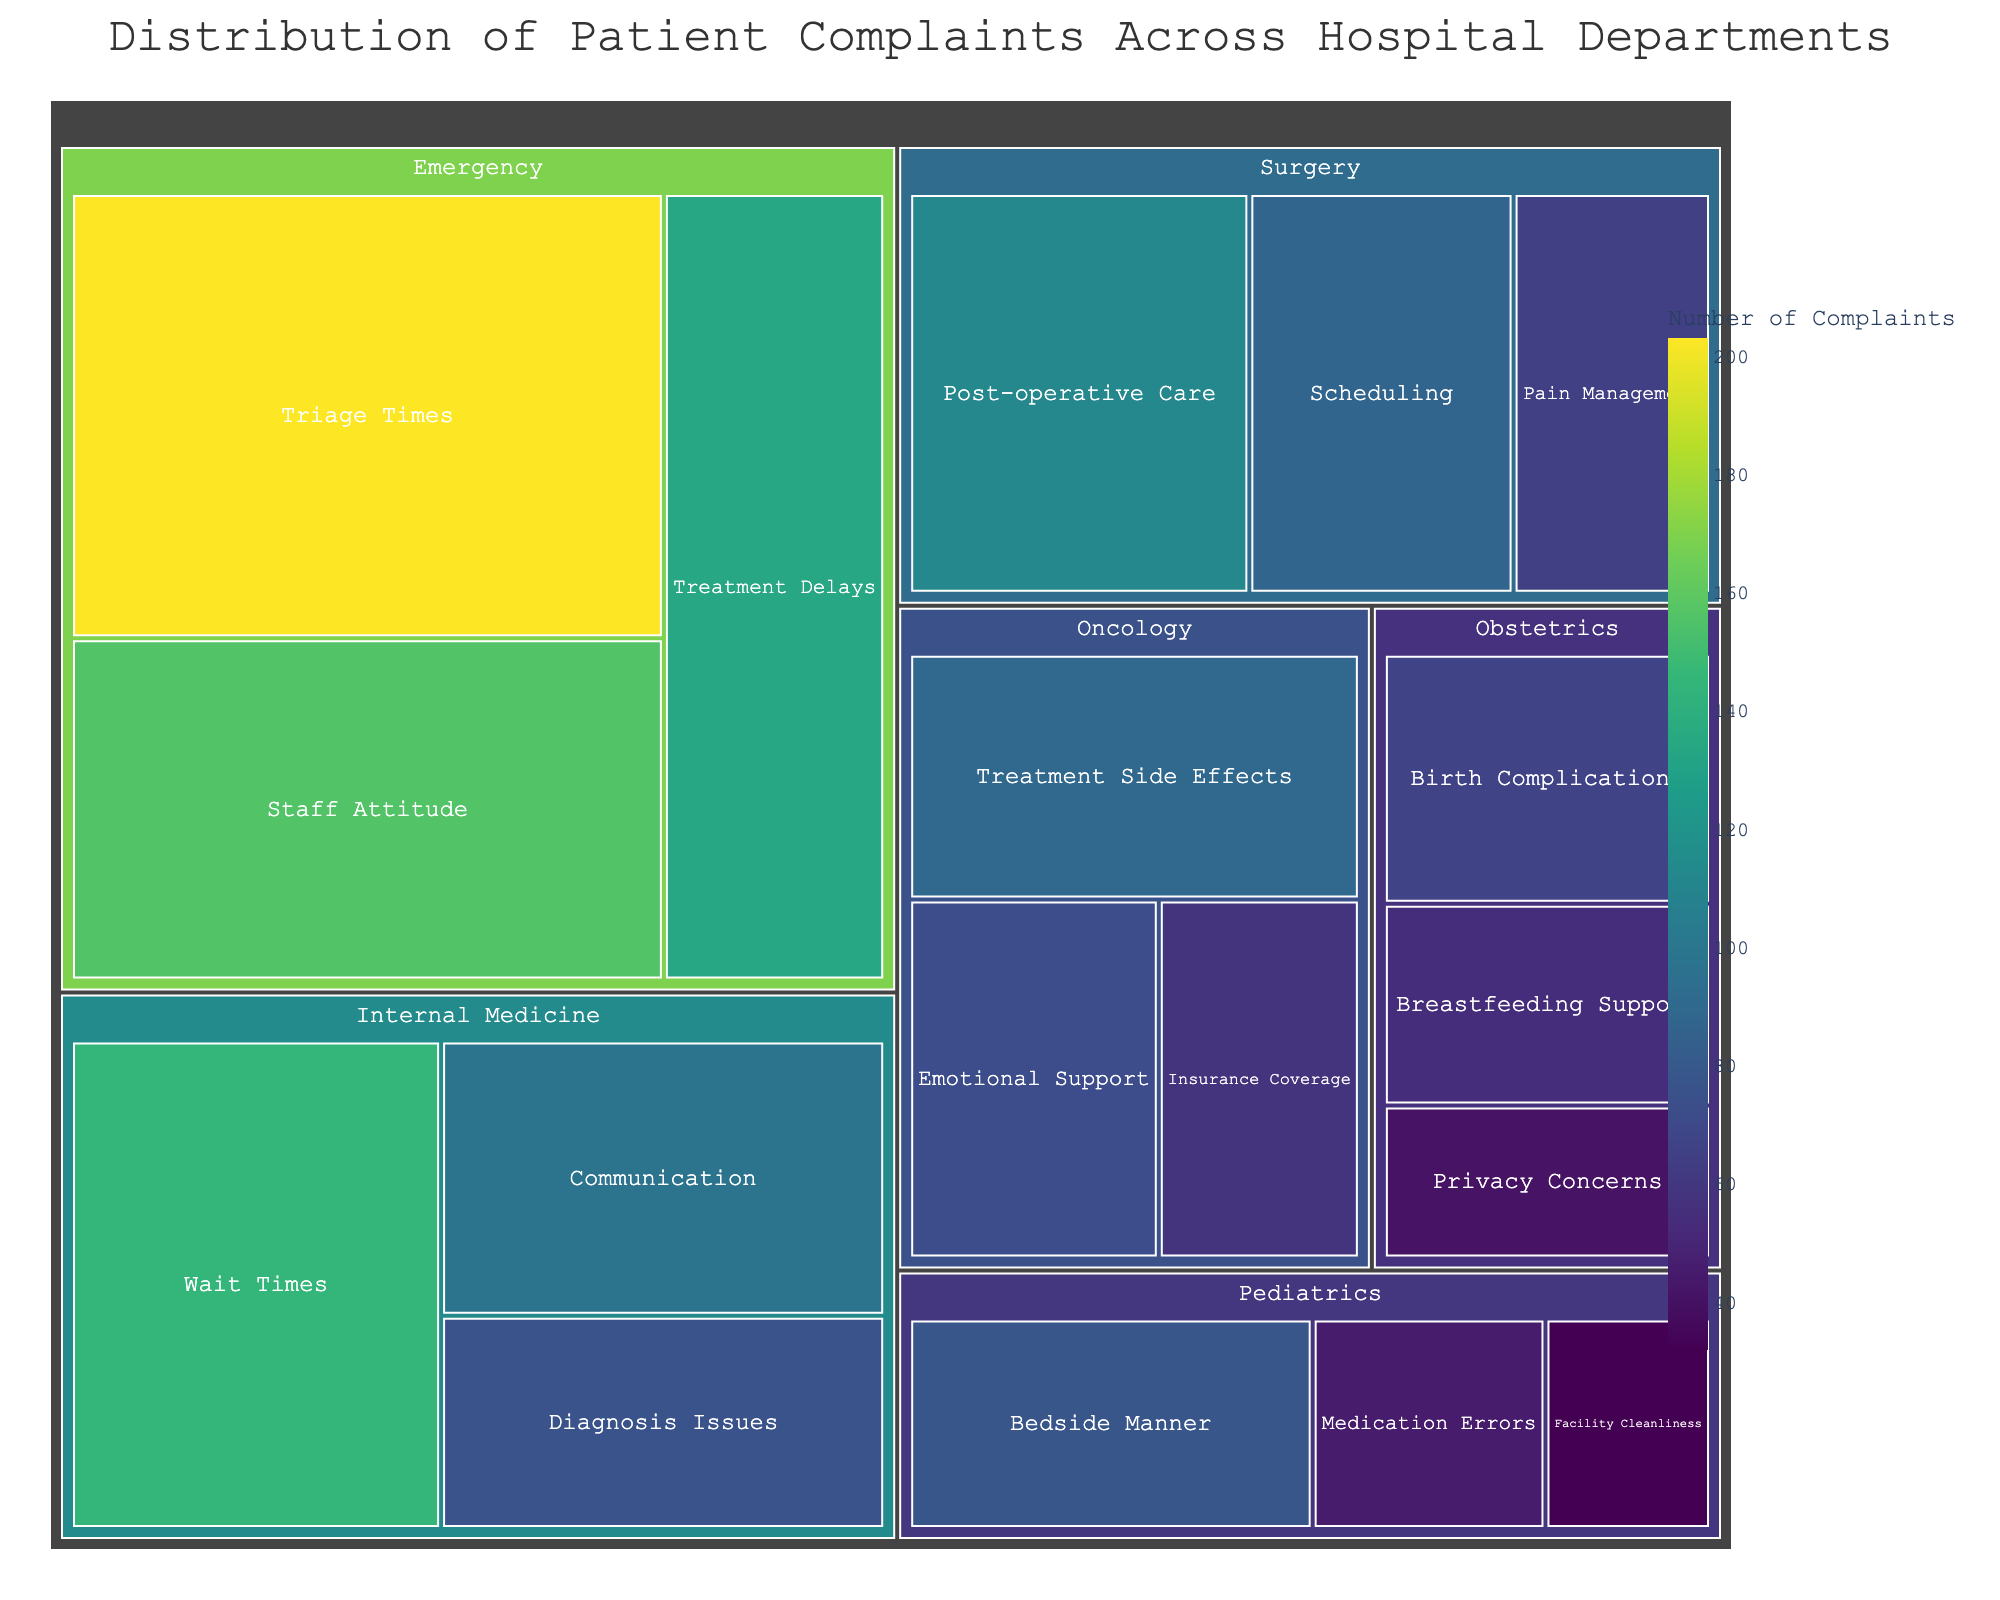What's the title of the treemap? The title is usually displayed prominently at the top of the plot. Here, it states 'Distribution of Patient Complaints Across Hospital Departments.'
Answer: Distribution of Patient Complaints Across Hospital Departments Which department has the greatest number of complaints related to triage times? Look under the 'Emergency' department section and identify the 'Triage Times' category to see the number of complaints.
Answer: Emergency What is the total number of complaints in the 'Oncology' department? Sum the complaints for each category in 'Oncology': Treatment Side Effects (89), Emotional Support (72), and Insurance Coverage (58). Calculate 89 + 72 + 58.
Answer: 219 Which category in the Internal Medicine department has the lowest number of complaints? Check the complaint numbers for each category in 'Internal Medicine': Wait Times (145), Communication (98), Diagnosis Issues (76). The smallest value indicates the lowest number.
Answer: Diagnosis Issues Compare 'Communication' complaints in Internal Medicine with 'Staff Attitude' complaints in Emergency. Which one is higher and by how much? Check the complaint numbers: Communication (98) in Internal Medicine and Staff Attitude (156) in Emergency. Subtract 98 from 156.
Answer: Staff Attitude by 58 What is the average number of complaints in the Surgery department categories? Calculate the sum of complaints in Surgery: Post-operative Care (112), Scheduling (87), Pain Management (65). Then divide by the number of categories (3). Compute (112 + 87 + 65) / 3.
Answer: 88 Which department has more complaints about 'Privacy Concerns,' Pediatrics or Obstetrics? Compare the numbers under each department: Pediatrics (not listed) and Obstetrics (41).
Answer: Obstetrics Identify the category with the highest number of complaints in the Pediatrics department. Look for the highest complaint number in Pediatrics among the categories: Bedside Manner (78), Medication Errors (45), Facility Cleanliness (32).
Answer: Bedside Manner What are the two main categories with the highest complaints in the Emergency department? List complaint numbers within the 'Emergency' department: Triage Times (203), Staff Attitude (156), Treatment Delays (134). Identify the top two numbers.
Answer: Triage Times, Staff Attitude 